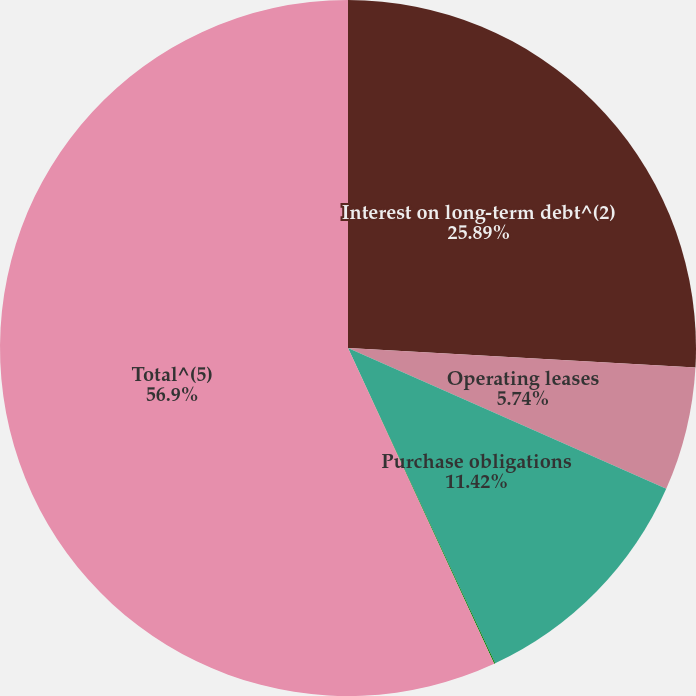Convert chart. <chart><loc_0><loc_0><loc_500><loc_500><pie_chart><fcel>Interest on long-term debt^(2)<fcel>Operating leases<fcel>Purchase obligations<fcel>Stand-by letters of<fcel>Total^(5)<nl><fcel>25.89%<fcel>5.74%<fcel>11.42%<fcel>0.05%<fcel>56.9%<nl></chart> 